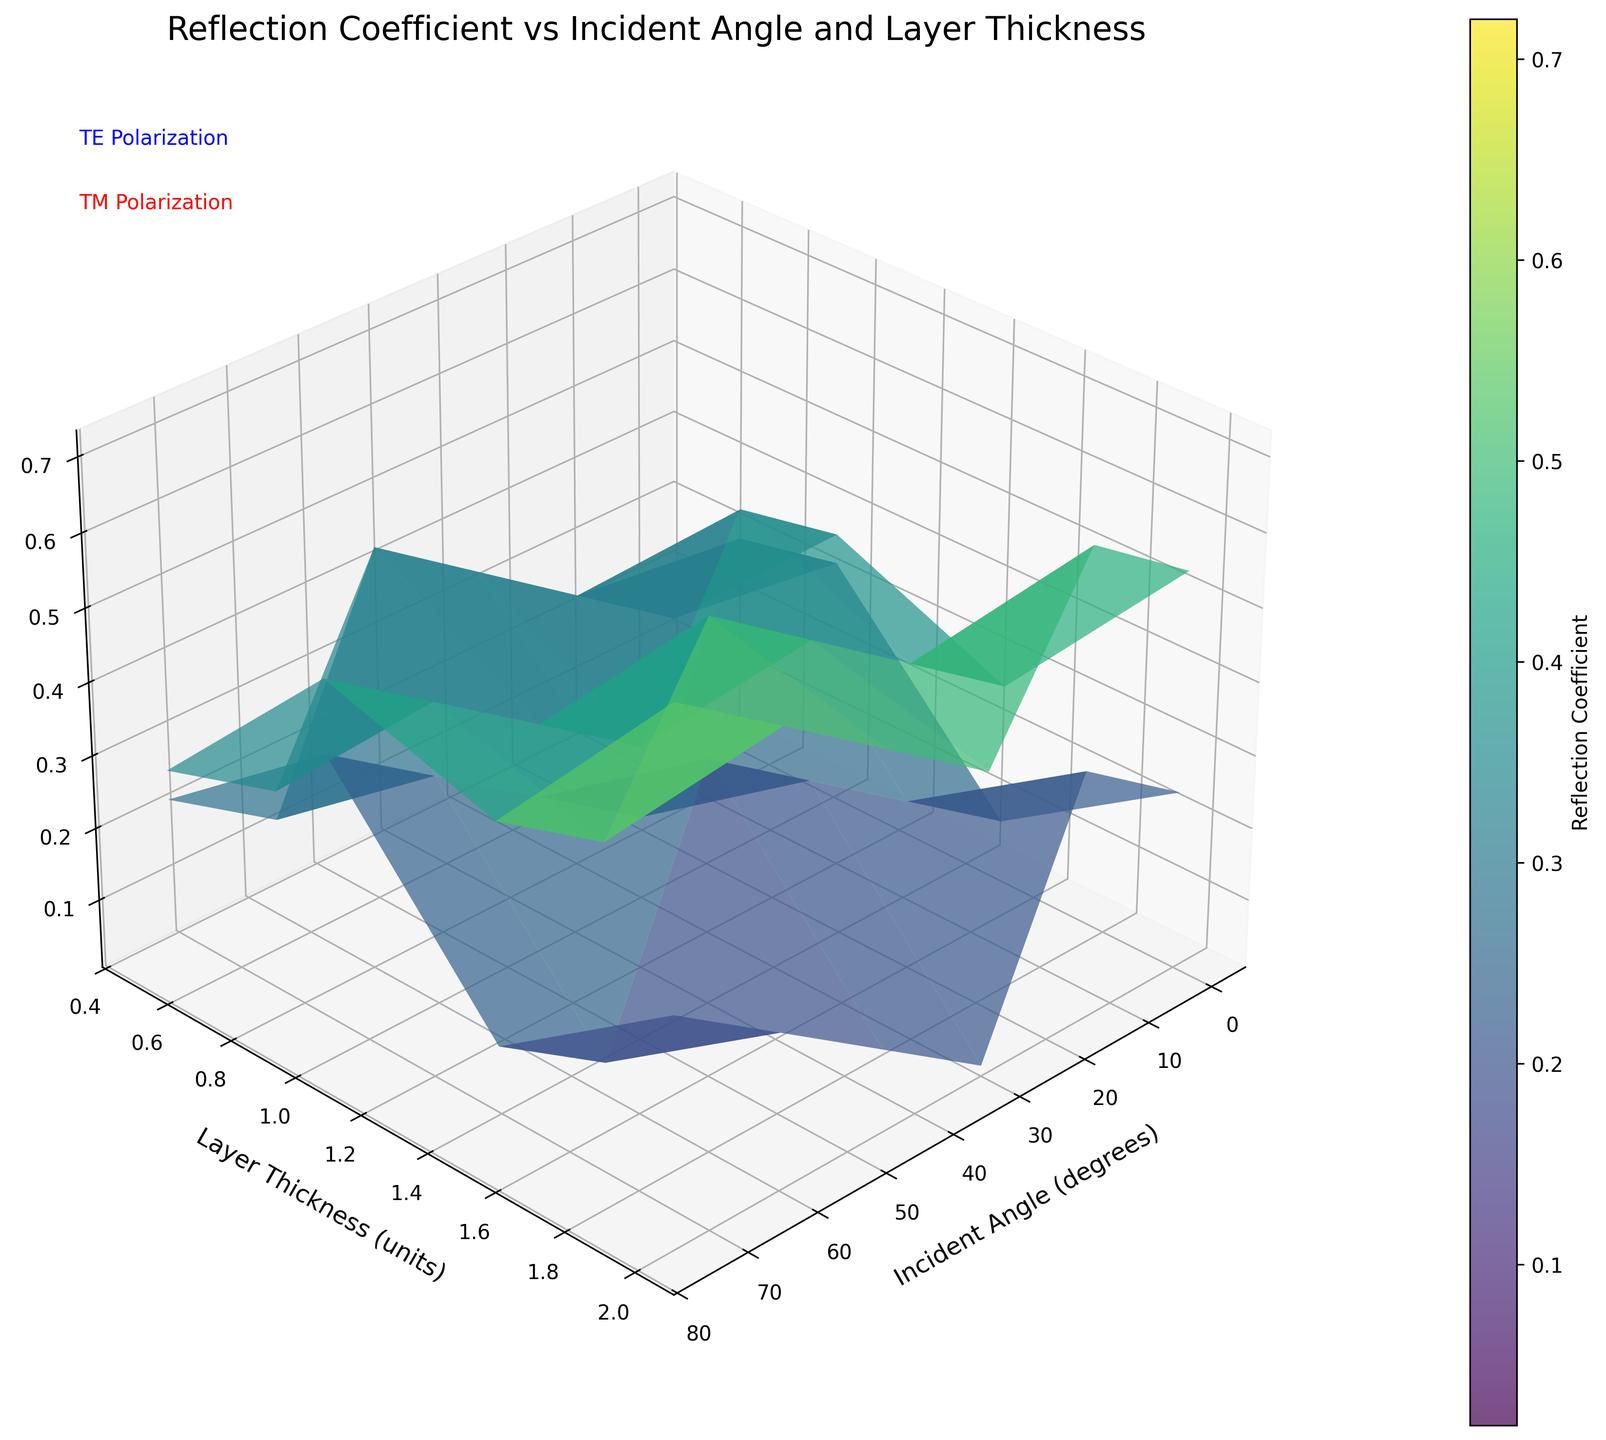What is the title of the figure? The title is shown at the top of the figure with the largest font size. It reads "Reflection Coefficient vs Incident Angle and Layer Thickness."
Answer: Reflection Coefficient vs Incident Angle and Layer Thickness What does the z-axis represent in the plot? The label on the z-axis specifies that it represents the "Reflection Coefficient."
Answer: Reflection Coefficient At layer thickness 2.0 units, which polarization has a higher reflection coefficient at an incident angle of 30 degrees? By looking at the plot at 2.0 units of layer thickness and 30 degrees of incident angle, we see that the surface representing TE polarization (likely the higher surface) has a coefficient much closer to 0.52, whereas TM is closer to 0.42.
Answer: TE polarization How does the reflection coefficient for TE polarization change as the incident angle increases from 0 to 75 degrees for a layer thickness of 0.5 units? Trace the surface plot for TE polarization (probably the more prominent) at a thickness of 0.5 units along the x-axis from 0 to 75 degrees. The coefficient starts at 0.15 and increases to 0.42.
Answer: It increases Which incident angle has the smallest reflection coefficient for TM polarization with a layer thickness of 0.5 units? Look for the lowest surface point for TM polarization (possibly the lower surface) across the x-axis at a thickness of 0.5 units. The TM coefficient at 60 degrees is 0.05, which is the smallest.
Answer: 60 degrees At an incident angle of 15 degrees, what is the difference in the reflection coefficient between the TE and TM polarizations for a layer thickness of 2.0 units? For 2.0 units thickness at 15 degrees, subtract the TM coefficient (0.44) from the TE coefficient (0.48). The difference is 0.48 - 0.44 = 0.04.
Answer: 0.04 For a fixed layer thickness of 1.0 unit, which polarization shows a larger increase in reflection coefficient when the incident angle changes from 45 degrees to 75 degrees? Find reflection coefficients for 1.0 unit thickness for both TE and TM at 45 degrees (TE: 0.38, TM: 0.19) and at 75 degrees (TE: 0.52, TM: 0.12). For TE, increase: 0.52 - 0.38 = 0.14. For TM, decrease: 0.19 - 0.12 = 0.07. TE shows a larger increase.
Answer: TE polarization What is the average reflection coefficient of TE polarization for layer thicknesses 1.5 and 2.0 units at an incident angle of 60 degrees? To find the average, add the TE reflection coefficients for 1.5 (0.55) and 2.0 (0.65) units and divide by 2. (0.55 + 0.65)/2 = 0.60.
Answer: 0.60 Is there any incident angle where both TE and TM reflection coefficients are equal? By comparing both surfaces visually, we observe that at an incident angle of 0 degrees for all layer thicknesses, TE and TM coefficients match (e.g., both 0.15 at 0.5 units).
Answer: Yes, at 0 degrees 